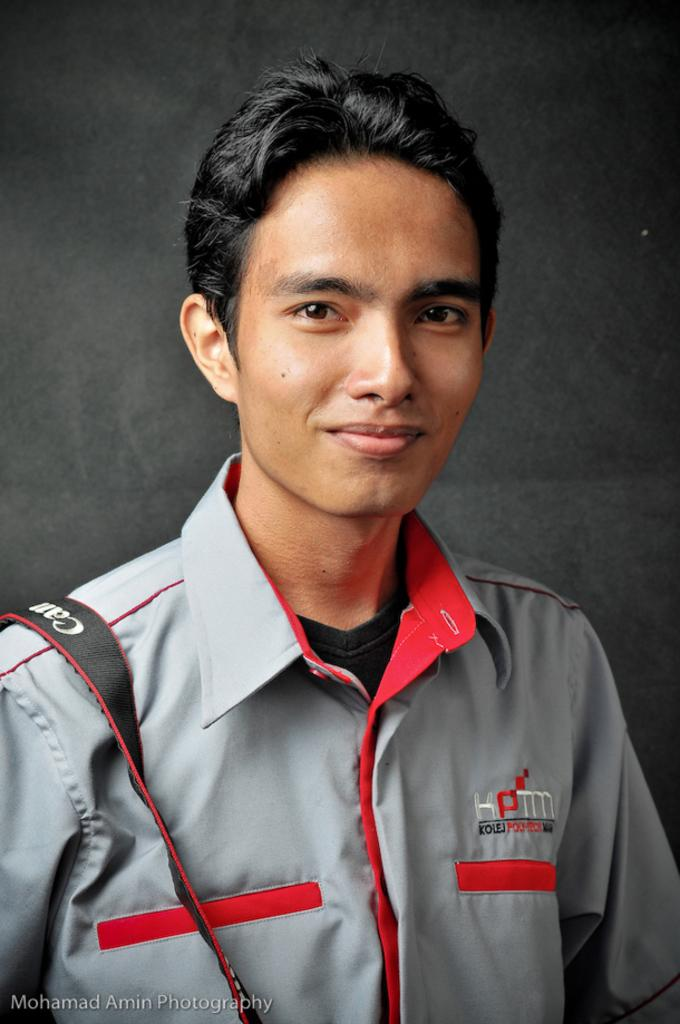<image>
Create a compact narrative representing the image presented. Man posing for a picture wearing a KPTM shirt. 